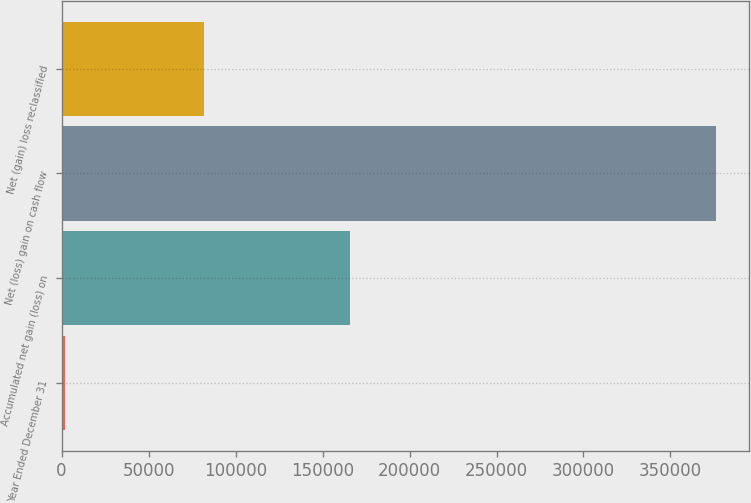<chart> <loc_0><loc_0><loc_500><loc_500><bar_chart><fcel>Year Ended December 31<fcel>Accumulated net gain (loss) on<fcel>Net (loss) gain on cash flow<fcel>Net (gain) loss reclassified<nl><fcel>2009<fcel>166028<fcel>376128<fcel>82092<nl></chart> 